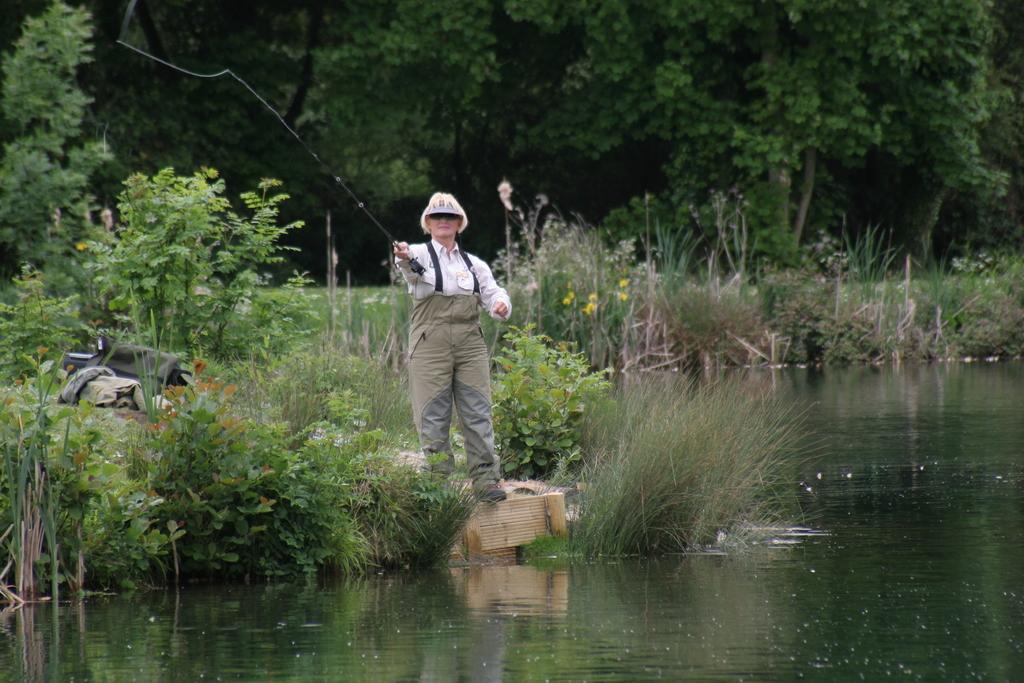Please provide a concise description of this image. In this picture we can see a person holding a fishing rod and standing on the ground. At the bottom of the image, there is water. Behind the person, there are plants, grass and trees. On the left side of the image, there are some objects. 